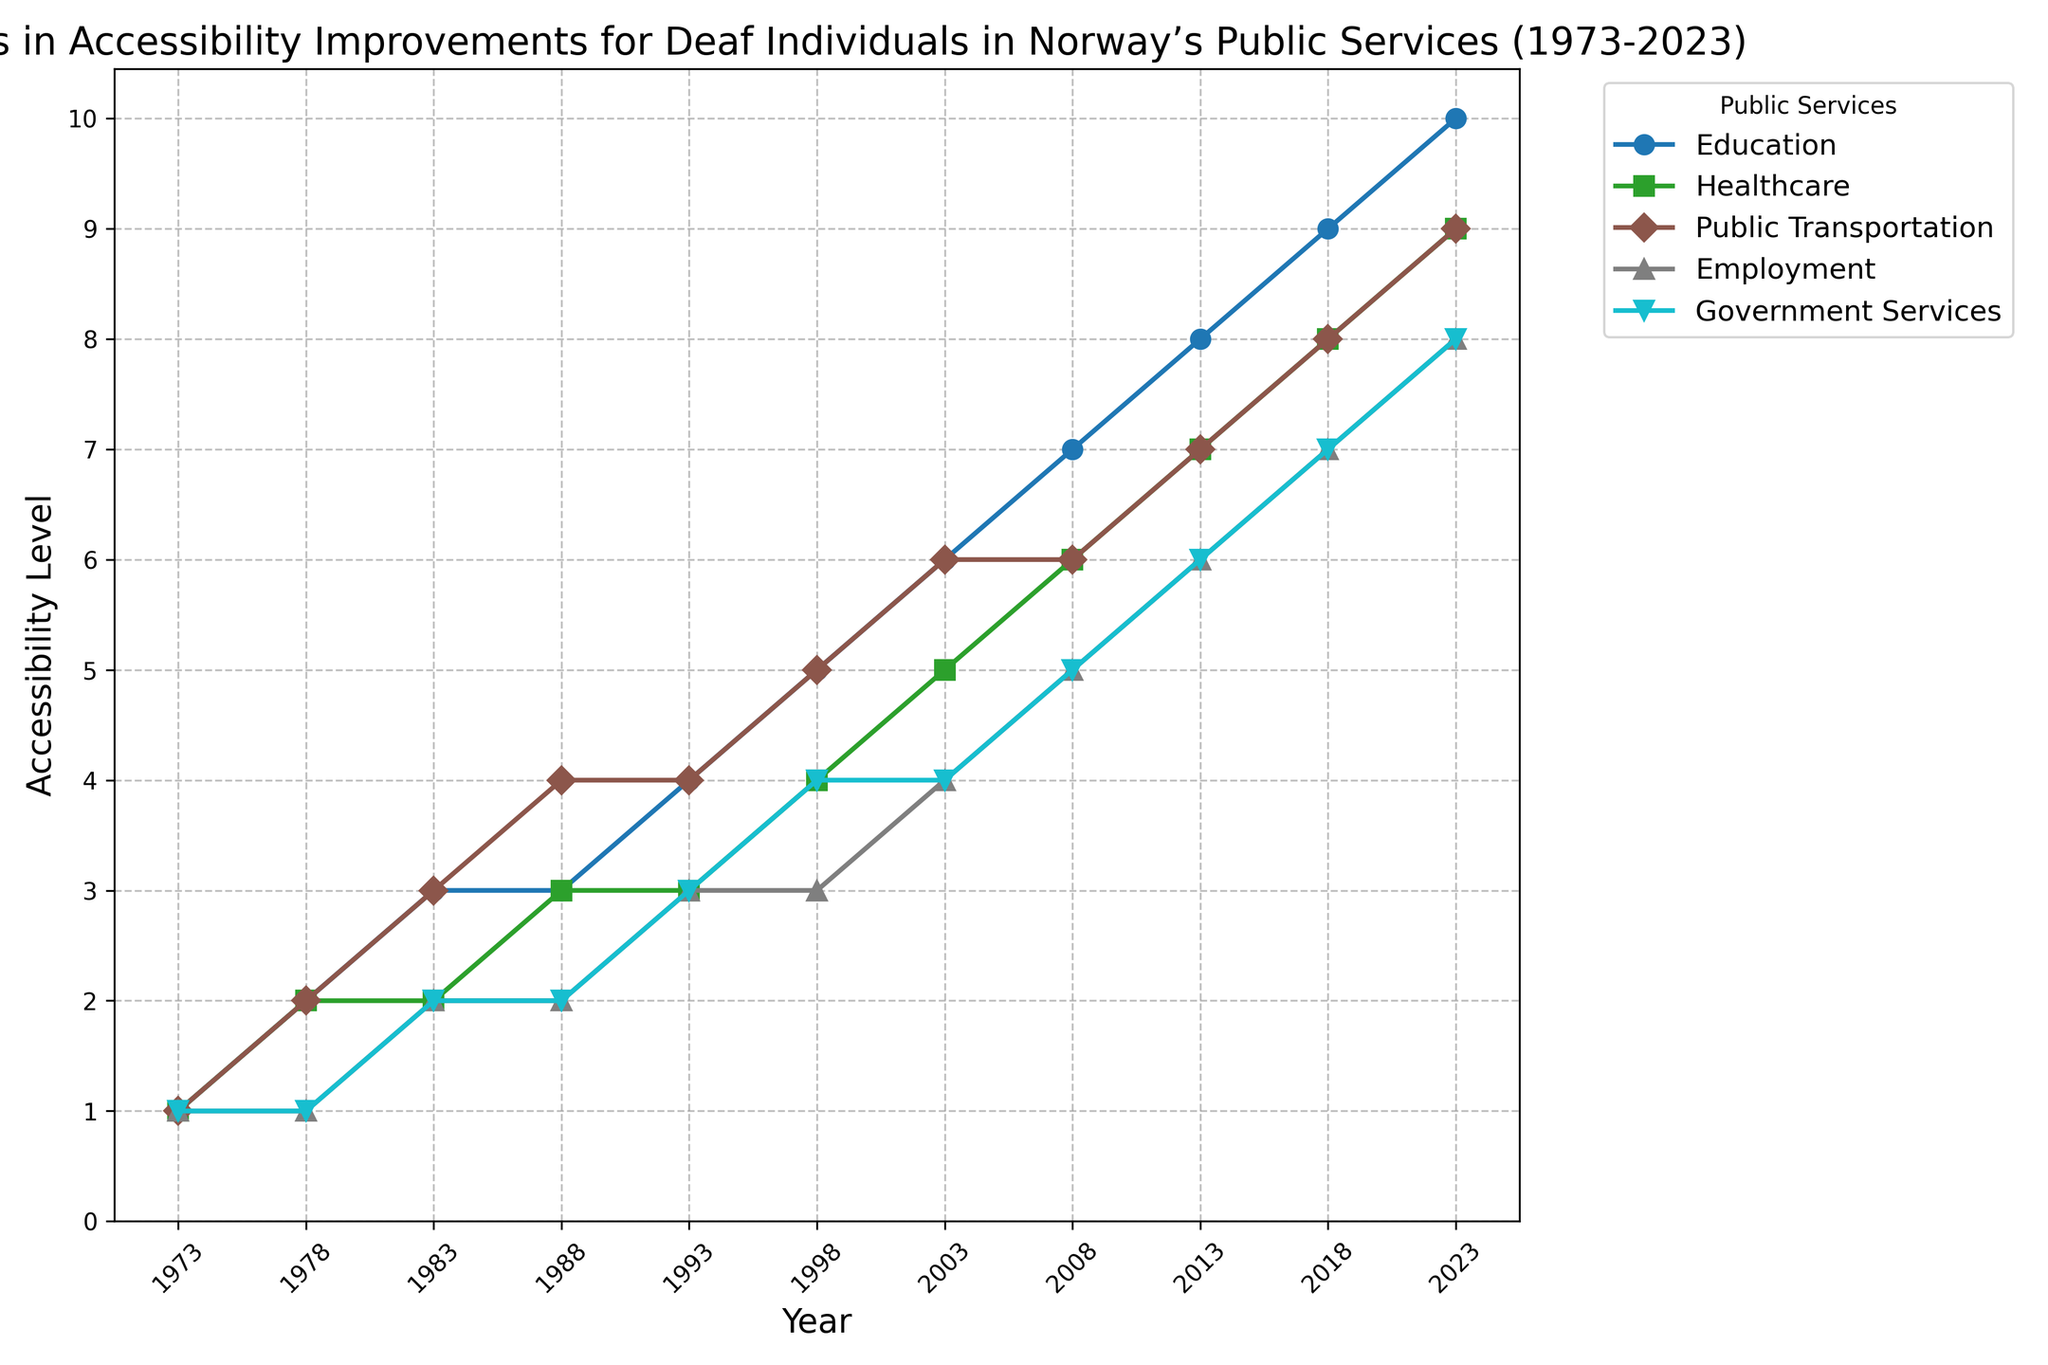What is the trend in accessibility level for Education from 1973 to 2023? The plot shows a steady increase in the accessibility level for Education over the years. Starting from the lowest level of 1 in 1973, the level gradually rises each subsequent period, reaching the highest level of 10 in 2023.
Answer: The trend is a consistent increase Which public service has shown the least improvement over the 50 years? By observing the final accessibility levels of all services in 2023, Employment has the lowest level at 8, compared to other services which have higher levels.
Answer: Employment In which year did Education and Healthcare first reach the same level of accessibility? Locate the years where Education and Healthcare levels intersect. Both services reached the level of 2 in 1978.
Answer: 1978 Which public service had the highest accessibility level in 1998, and what was its level? In 1998, Education had the highest accessibility level among all services, with a level of 5.
Answer: Education, 5 What is the average accessibility level for Government Services over the 50 years? The levels from 1973 to 2023 are: 1, 1, 2, 2, 3, 4, 4, 5, 6, 7, 8. Summing these gives 43. Dividing by 11 (number of years) yields approximately 3.91.
Answer: 3.91 By how much did the accessibility level for Public Transportation change from 1983 to 2013? In 1983, the level for Public Transportation was 3; in 2013, it was 7. The difference is 7 - 3 = 4.
Answer: 4 What is the difference in accessibility level between Healthcare and Public Transportation in 2008? In 2008, Healthcare's level was 6 and Public Transportation's level was also 6. The difference is 6 - 6 = 0.
Answer: 0 Comparing the growth of Employment from 1973 to 2023 to the growth of Education in the same period, which had a higher initial and final increase? Education increased from 1 to 10 (9 points), while Employment increased from 1 to 8 (7 points). Education showed both a higher initial and final increase.
Answer: Education Which year saw the largest single-year increase in accessibility level for any service, and what was the increase? Public Transportation saw its largest increase from 1983 to 1988, rising from 3 to 4. The increase is 1 level.
Answer: 1988, 1 How many times did the accessibility level for Government Services change over the 50 years? The accessibility levels change from one value to another at each listed year. In the 11 listed years, the levels changed 8 times.
Answer: 8 